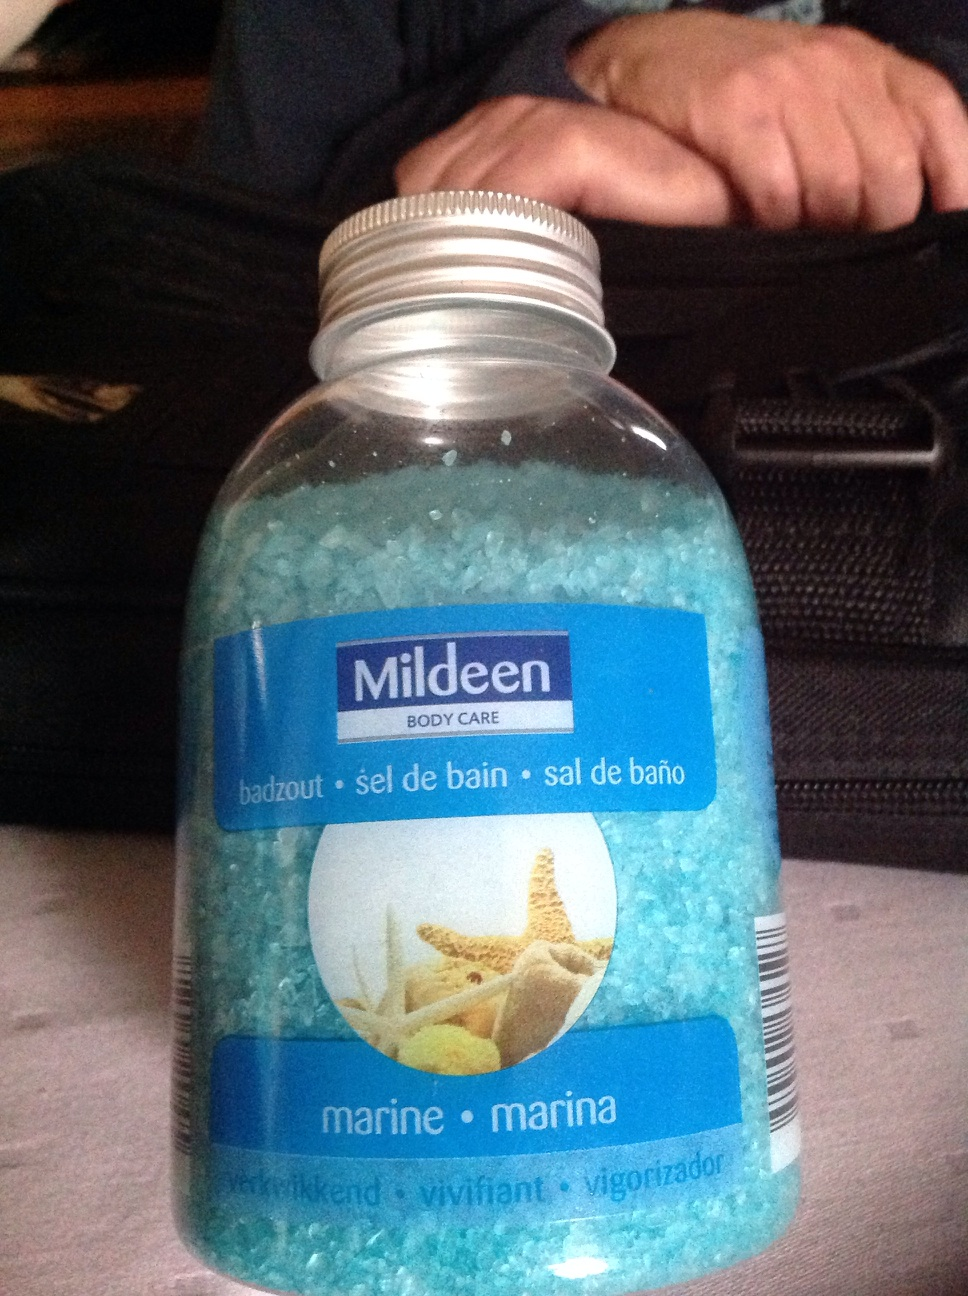Can you tell me more about the brand 'Mildeen'? Mildeen is a brand that typically offers various personal care products including bath salts, skincare items, and more. They focus on quality products at affordable prices, often found in convenience stores or pharmacies. 